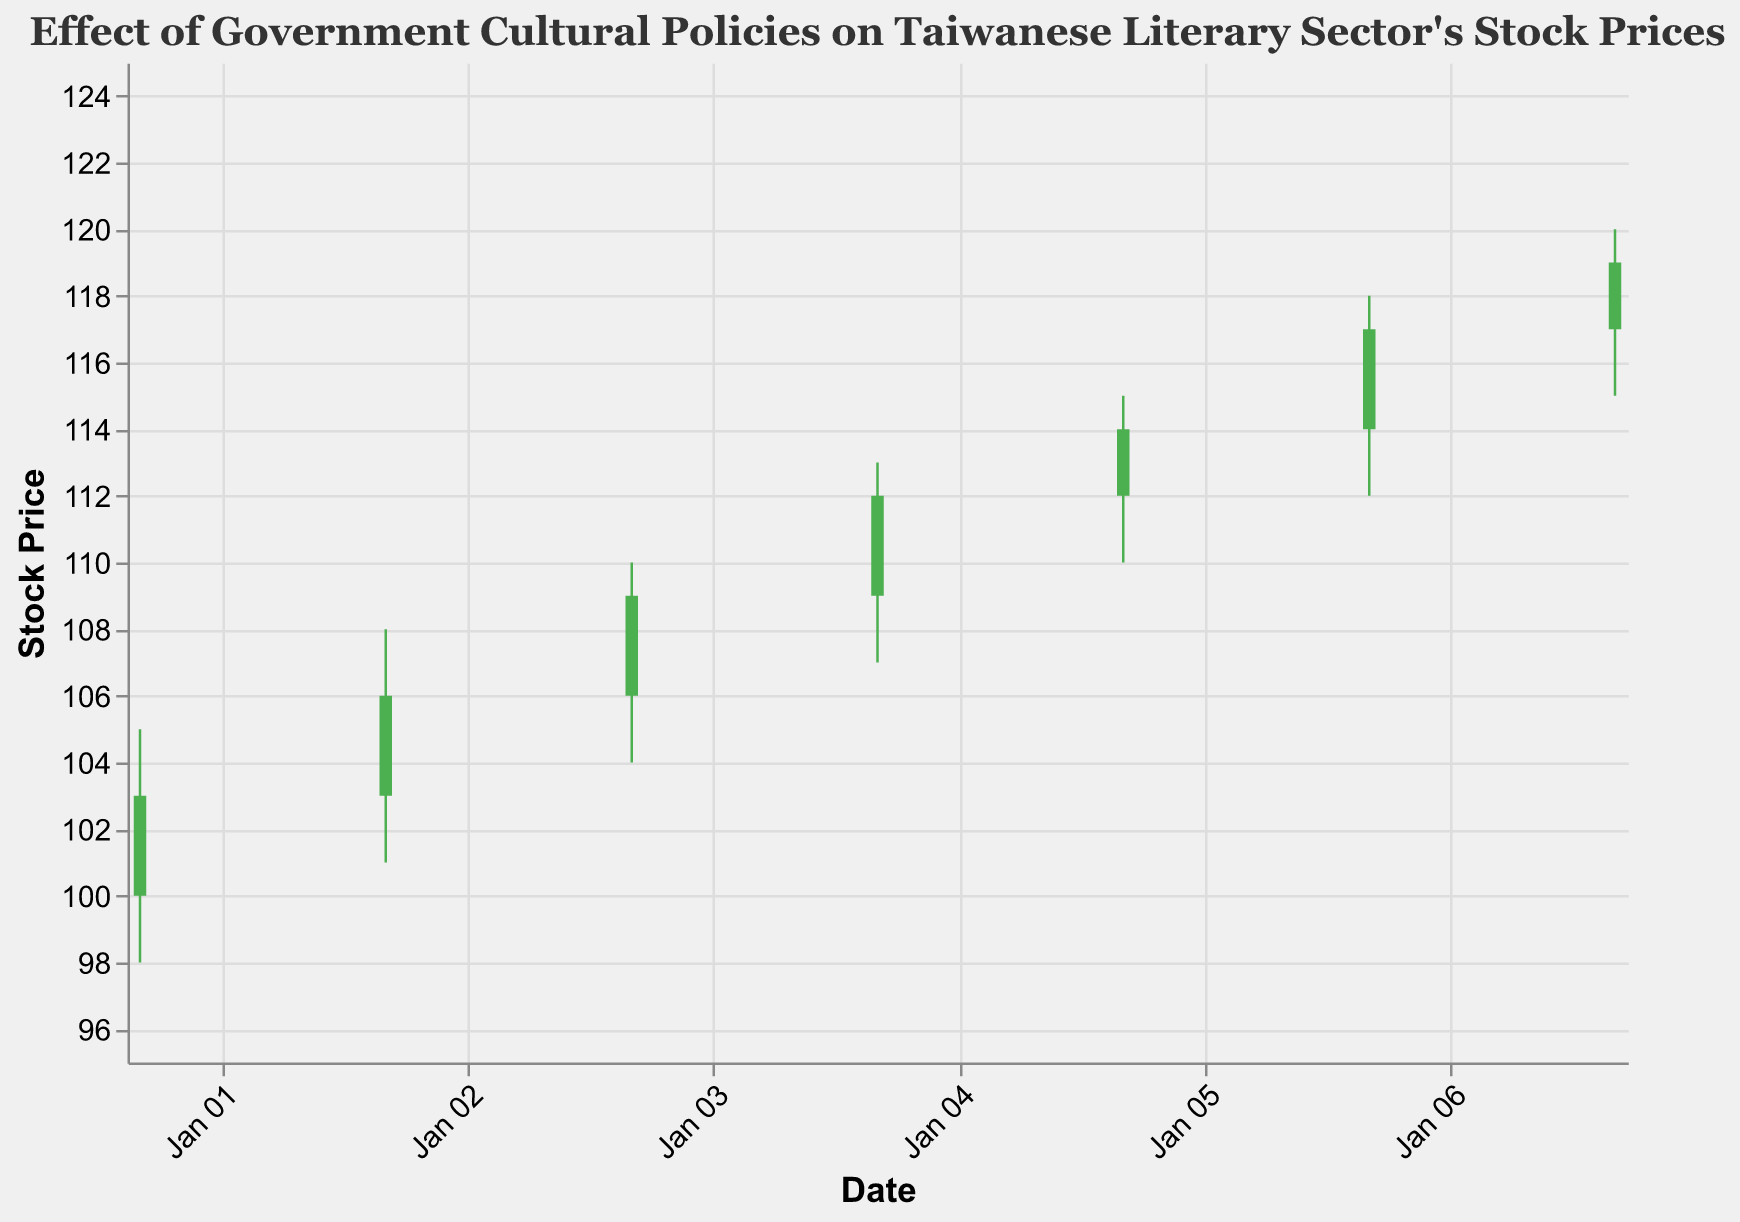What is the title of the figure? The title is usually prominently displayed at the top of a figure. In this case, it is "Effect of Government Cultural Policies on Taiwanese Literary Sector's Stock Prices".
Answer: Effect of Government Cultural Policies on Taiwanese Literary Sector's Stock Prices Which date experienced the highest stock price (High) in this dataset? The highest stock price in the dataset can be seen from the highest value on the "High" axis among the candlesticks. On January 7, 2023, the "High" value reached 120, the highest in the figure.
Answer: January 7, 2023 What event corresponds to the largest trading volume? The largest trading volume is represented by the tallest vertical line among the small lines at the bottom of the candlesticks. This corresponds to the "Introduction of Digital Literary Services" on January 7, 2023.
Answer: Introduction of Digital Literary Services On which date did the stock price increase the most from the Open to the Close price? To find the largest increase, we compare the difference (Close - Open) for each date. The date with the greatest difference is January 3, 2023, with a Close of 109 and an Open of 106, resulting in an increase of 3.
Answer: January 3, 2023 How many days show a green candlestick? Green candlesticks indicate days where the Close price was higher than the Open price. By visually counting these, there are 6 days where green candlesticks appear.
Answer: 6 What was the stock price range (High - Low) on January 5, 2023? The range is found by subtracting the Low price from the High price for January 5. The High is 115 and the Low is 110, so the range is 115 - 110 = 5.
Answer: 5 What is the median closing price for the dates illustrated? To find the median, we list the closing prices: 103, 106, 109, 112, 114, 117, 119. The median (middle value) in this sorted list is 112.
Answer: 112 Which dates show a red candlestick, where the Open price was higher than the Close price? Red candlesticks indicate days where the Open price was higher than the Close price. Upon inspection, January 1, 2023, is the only day with a red candlestick.
Answer: January 1, 2023 